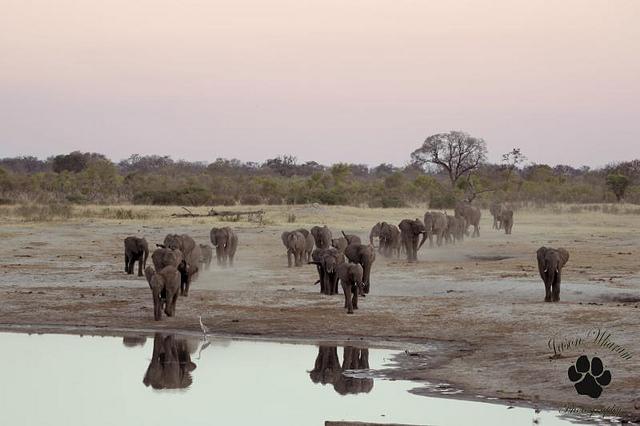Is it night time?
Keep it brief. No. Is this a stampede?
Short answer required. Yes. What type of animal is in the photo?
Quick response, please. Elephant. 